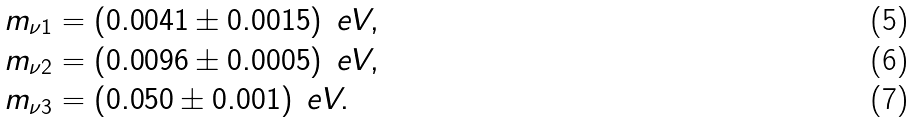Convert formula to latex. <formula><loc_0><loc_0><loc_500><loc_500>m _ { \nu 1 } & = ( 0 . 0 0 4 1 \pm 0 . 0 0 1 5 ) \, \ e V , \\ m _ { \nu 2 } & = ( 0 . 0 0 9 6 \pm 0 . 0 0 0 5 ) \, \ e V , \\ m _ { \nu 3 } & = ( 0 . 0 5 0 \pm 0 . 0 0 1 ) \, \ e V .</formula> 